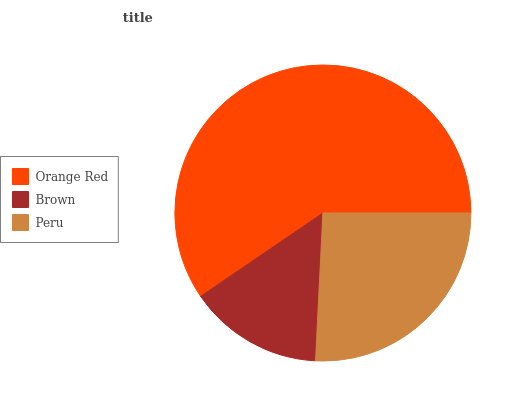Is Brown the minimum?
Answer yes or no. Yes. Is Orange Red the maximum?
Answer yes or no. Yes. Is Peru the minimum?
Answer yes or no. No. Is Peru the maximum?
Answer yes or no. No. Is Peru greater than Brown?
Answer yes or no. Yes. Is Brown less than Peru?
Answer yes or no. Yes. Is Brown greater than Peru?
Answer yes or no. No. Is Peru less than Brown?
Answer yes or no. No. Is Peru the high median?
Answer yes or no. Yes. Is Peru the low median?
Answer yes or no. Yes. Is Orange Red the high median?
Answer yes or no. No. Is Brown the low median?
Answer yes or no. No. 